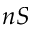Convert formula to latex. <formula><loc_0><loc_0><loc_500><loc_500>n S</formula> 